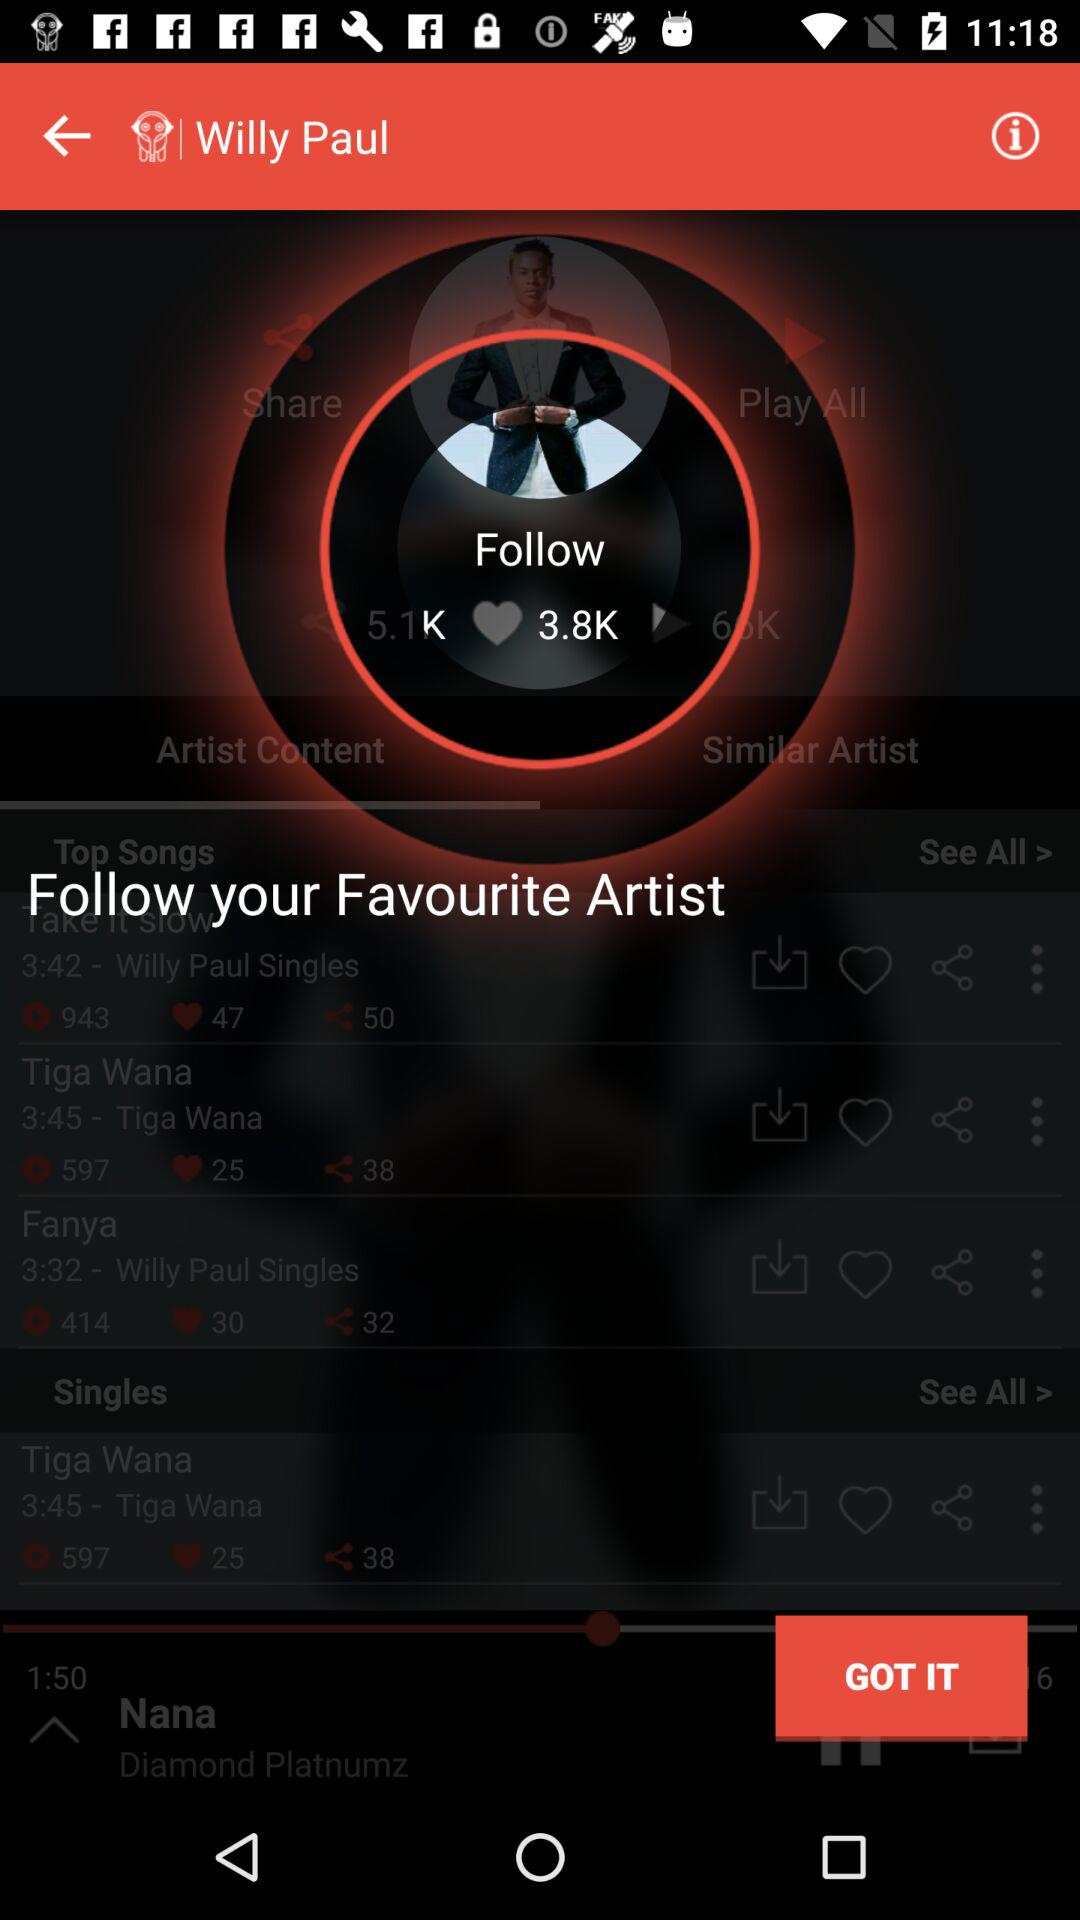How many likes are there for the song "Fanya"? There are 30 likes. 